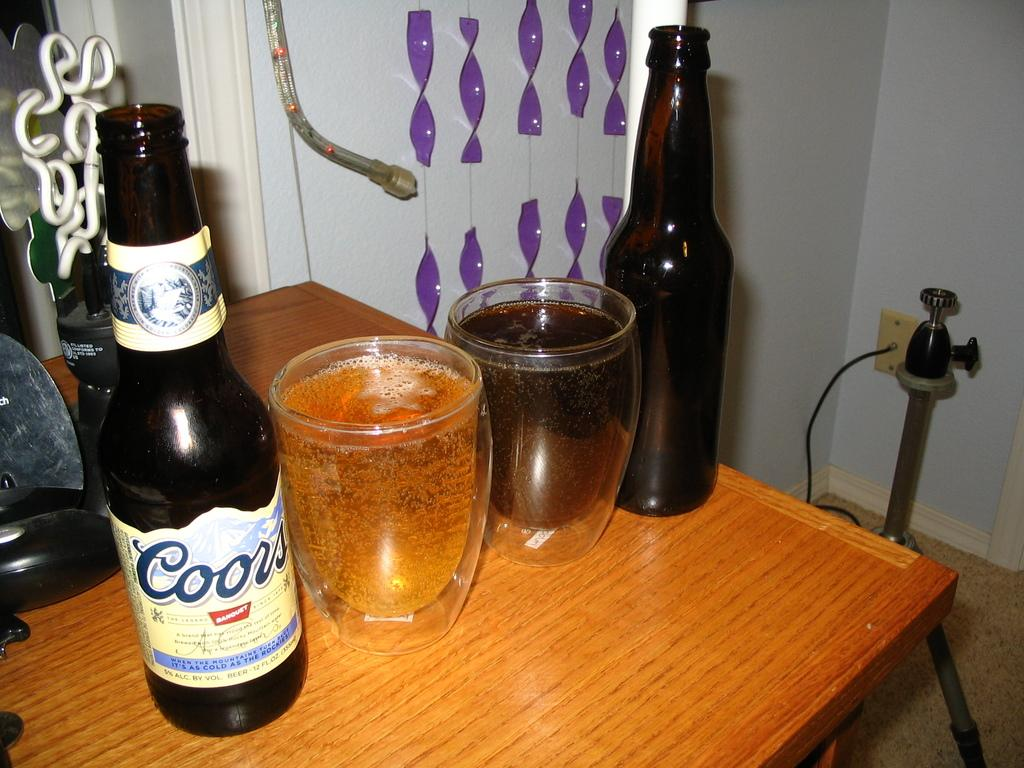<image>
Share a concise interpretation of the image provided. One Coors bottle next to two glasses of beer and another beer bottle. 